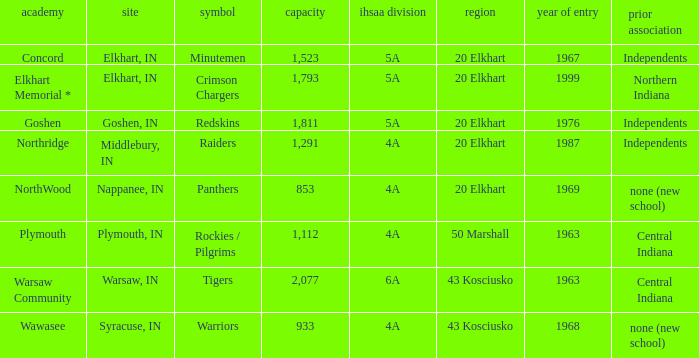What country joined before 1976, with IHSSA class of 5a, and a size larger than 1,112? 20 Elkhart. 